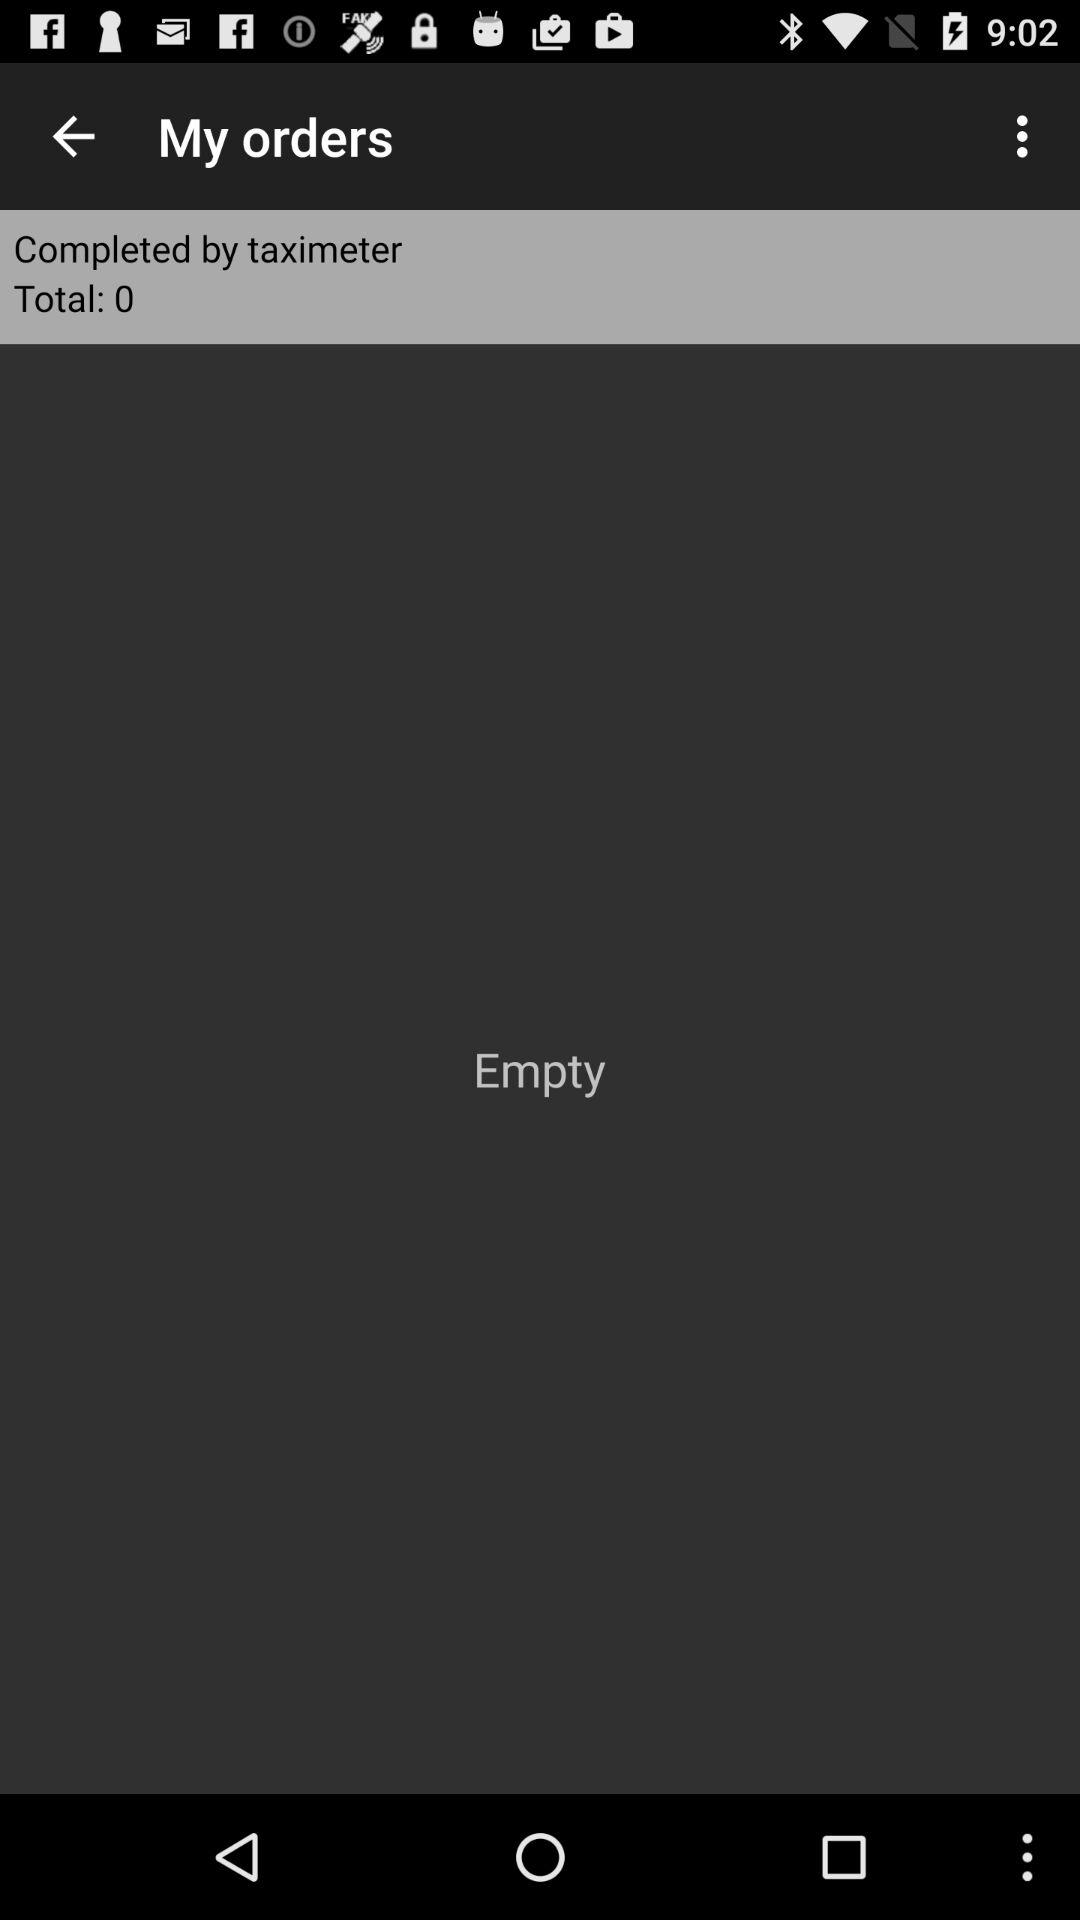What is the total number of orders completed by taximeter? The total number of orders is 0. 